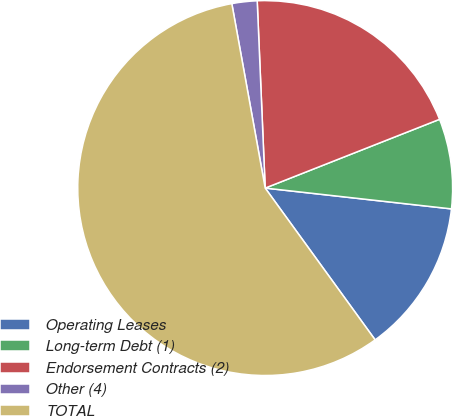Convert chart to OTSL. <chart><loc_0><loc_0><loc_500><loc_500><pie_chart><fcel>Operating Leases<fcel>Long-term Debt (1)<fcel>Endorsement Contracts (2)<fcel>Other (4)<fcel>TOTAL<nl><fcel>13.25%<fcel>7.75%<fcel>19.7%<fcel>2.17%<fcel>57.13%<nl></chart> 